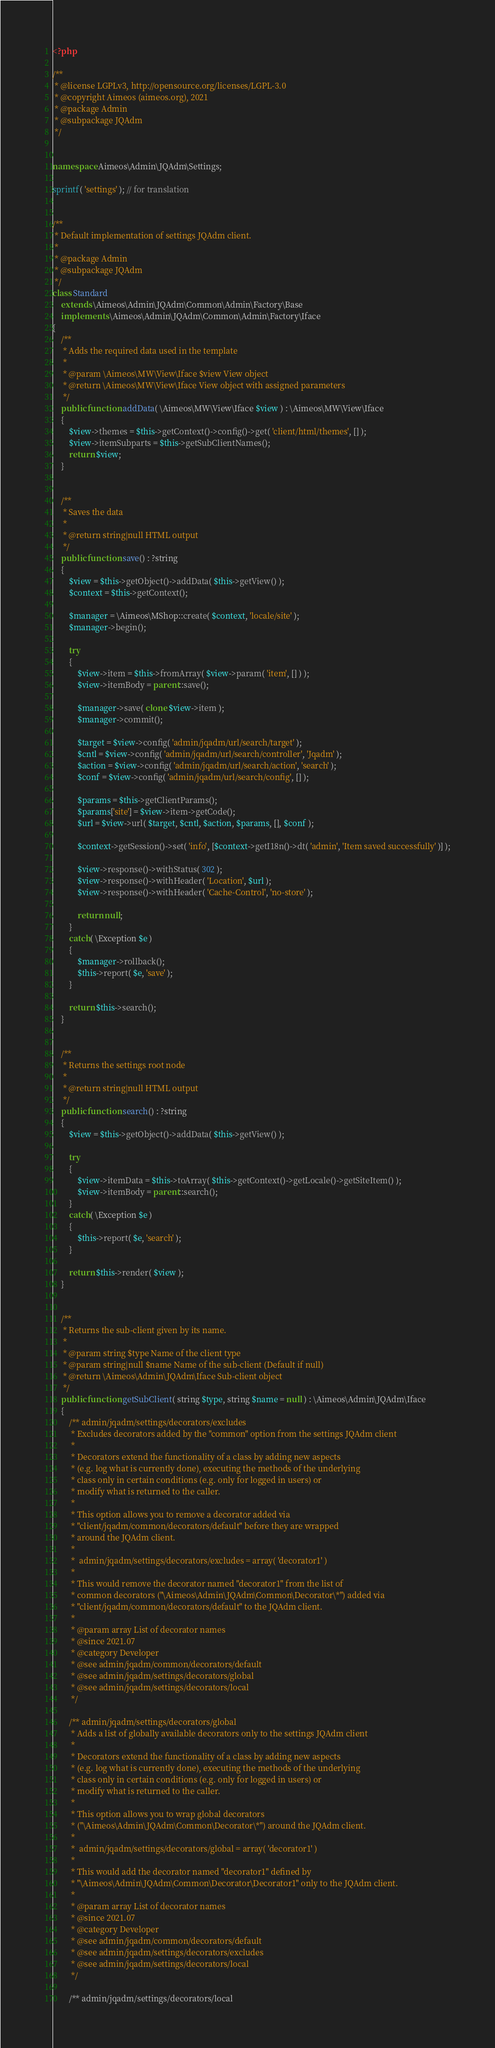Convert code to text. <code><loc_0><loc_0><loc_500><loc_500><_PHP_><?php

/**
 * @license LGPLv3, http://opensource.org/licenses/LGPL-3.0
 * @copyright Aimeos (aimeos.org), 2021
 * @package Admin
 * @subpackage JQAdm
 */


namespace Aimeos\Admin\JQAdm\Settings;

sprintf( 'settings' ); // for translation


/**
 * Default implementation of settings JQAdm client.
 *
 * @package Admin
 * @subpackage JQAdm
 */
class Standard
	extends \Aimeos\Admin\JQAdm\Common\Admin\Factory\Base
	implements \Aimeos\Admin\JQAdm\Common\Admin\Factory\Iface
{
	/**
	 * Adds the required data used in the template
	 *
	 * @param \Aimeos\MW\View\Iface $view View object
	 * @return \Aimeos\MW\View\Iface View object with assigned parameters
	 */
	public function addData( \Aimeos\MW\View\Iface $view ) : \Aimeos\MW\View\Iface
	{
		$view->themes = $this->getContext()->config()->get( 'client/html/themes', [] );
		$view->itemSubparts = $this->getSubClientNames();
		return $view;
	}


	/**
	 * Saves the data
	 *
	 * @return string|null HTML output
	 */
	public function save() : ?string
	{
		$view = $this->getObject()->addData( $this->getView() );
		$context = $this->getContext();

		$manager = \Aimeos\MShop::create( $context, 'locale/site' );
		$manager->begin();

		try
		{
			$view->item = $this->fromArray( $view->param( 'item', [] ) );
			$view->itemBody = parent::save();

			$manager->save( clone $view->item );
			$manager->commit();

			$target = $view->config( 'admin/jqadm/url/search/target' );
			$cntl = $view->config( 'admin/jqadm/url/search/controller', 'Jqadm' );
			$action = $view->config( 'admin/jqadm/url/search/action', 'search' );
			$conf = $view->config( 'admin/jqadm/url/search/config', [] );

			$params = $this->getClientParams();
			$params['site'] = $view->item->getCode();
			$url = $view->url( $target, $cntl, $action, $params, [], $conf );

			$context->getSession()->set( 'info', [$context->getI18n()->dt( 'admin', 'Item saved successfully' )] );

			$view->response()->withStatus( 302 );
			$view->response()->withHeader( 'Location', $url );
			$view->response()->withHeader( 'Cache-Control', 'no-store' );

			return null;
		}
		catch( \Exception $e )
		{
			$manager->rollback();
			$this->report( $e, 'save' );
		}

		return $this->search();
	}


	/**
	 * Returns the settings root node
	 *
	 * @return string|null HTML output
	 */
	public function search() : ?string
	{
		$view = $this->getObject()->addData( $this->getView() );

		try
		{
			$view->itemData = $this->toArray( $this->getContext()->getLocale()->getSiteItem() );
			$view->itemBody = parent::search();
		}
		catch( \Exception $e )
		{
			$this->report( $e, 'search' );
		}

		return $this->render( $view );
	}


	/**
	 * Returns the sub-client given by its name.
	 *
	 * @param string $type Name of the client type
	 * @param string|null $name Name of the sub-client (Default if null)
	 * @return \Aimeos\Admin\JQAdm\Iface Sub-client object
	 */
	public function getSubClient( string $type, string $name = null ) : \Aimeos\Admin\JQAdm\Iface
	{
		/** admin/jqadm/settings/decorators/excludes
		 * Excludes decorators added by the "common" option from the settings JQAdm client
		 *
		 * Decorators extend the functionality of a class by adding new aspects
		 * (e.g. log what is currently done), executing the methods of the underlying
		 * class only in certain conditions (e.g. only for logged in users) or
		 * modify what is returned to the caller.
		 *
		 * This option allows you to remove a decorator added via
		 * "client/jqadm/common/decorators/default" before they are wrapped
		 * around the JQAdm client.
		 *
		 *  admin/jqadm/settings/decorators/excludes = array( 'decorator1' )
		 *
		 * This would remove the decorator named "decorator1" from the list of
		 * common decorators ("\Aimeos\Admin\JQAdm\Common\Decorator\*") added via
		 * "client/jqadm/common/decorators/default" to the JQAdm client.
		 *
		 * @param array List of decorator names
		 * @since 2021.07
		 * @category Developer
		 * @see admin/jqadm/common/decorators/default
		 * @see admin/jqadm/settings/decorators/global
		 * @see admin/jqadm/settings/decorators/local
		 */

		/** admin/jqadm/settings/decorators/global
		 * Adds a list of globally available decorators only to the settings JQAdm client
		 *
		 * Decorators extend the functionality of a class by adding new aspects
		 * (e.g. log what is currently done), executing the methods of the underlying
		 * class only in certain conditions (e.g. only for logged in users) or
		 * modify what is returned to the caller.
		 *
		 * This option allows you to wrap global decorators
		 * ("\Aimeos\Admin\JQAdm\Common\Decorator\*") around the JQAdm client.
		 *
		 *  admin/jqadm/settings/decorators/global = array( 'decorator1' )
		 *
		 * This would add the decorator named "decorator1" defined by
		 * "\Aimeos\Admin\JQAdm\Common\Decorator\Decorator1" only to the JQAdm client.
		 *
		 * @param array List of decorator names
		 * @since 2021.07
		 * @category Developer
		 * @see admin/jqadm/common/decorators/default
		 * @see admin/jqadm/settings/decorators/excludes
		 * @see admin/jqadm/settings/decorators/local
		 */

		/** admin/jqadm/settings/decorators/local</code> 